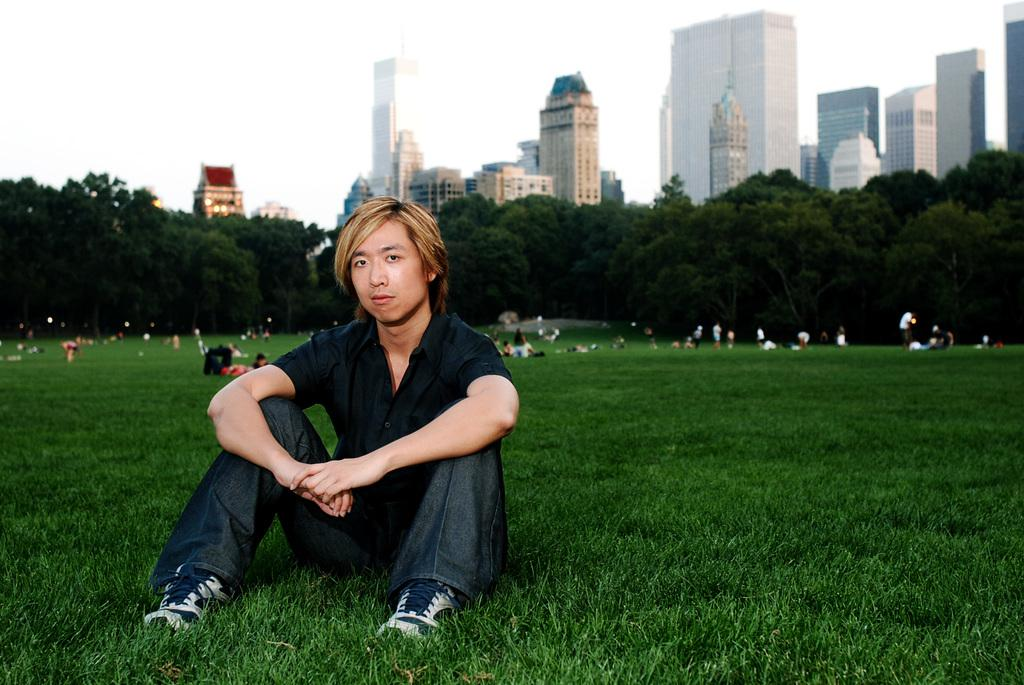What is the main subject in the foreground of the image? There is a man sitting in the foreground of the image. What can be seen in the background of the image? There are many people, trees, and buildings in the background of the image. Where is the basin located in the image? There is no basin present in the image. What type of clam can be seen interacting with the people in the background? There are no clams present in the image; it features people and buildings in the background. 